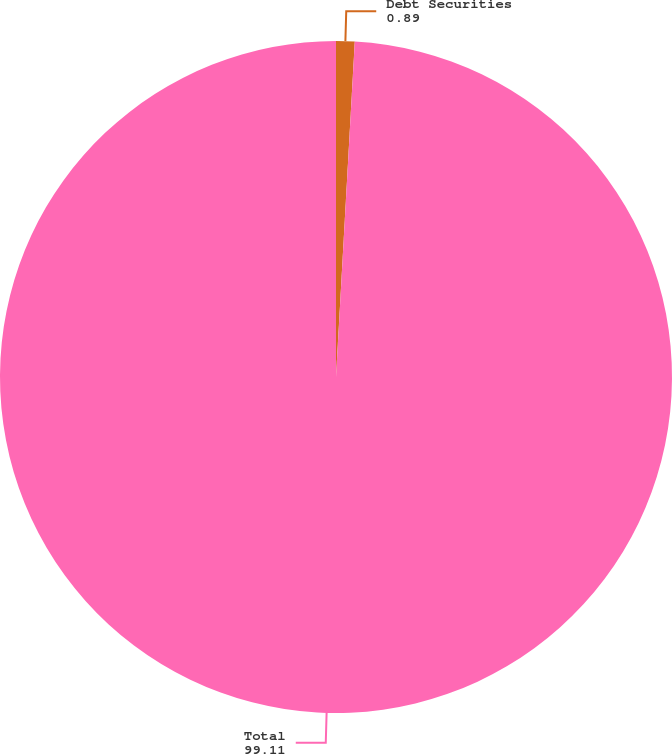Convert chart. <chart><loc_0><loc_0><loc_500><loc_500><pie_chart><fcel>Debt Securities<fcel>Total<nl><fcel>0.89%<fcel>99.11%<nl></chart> 